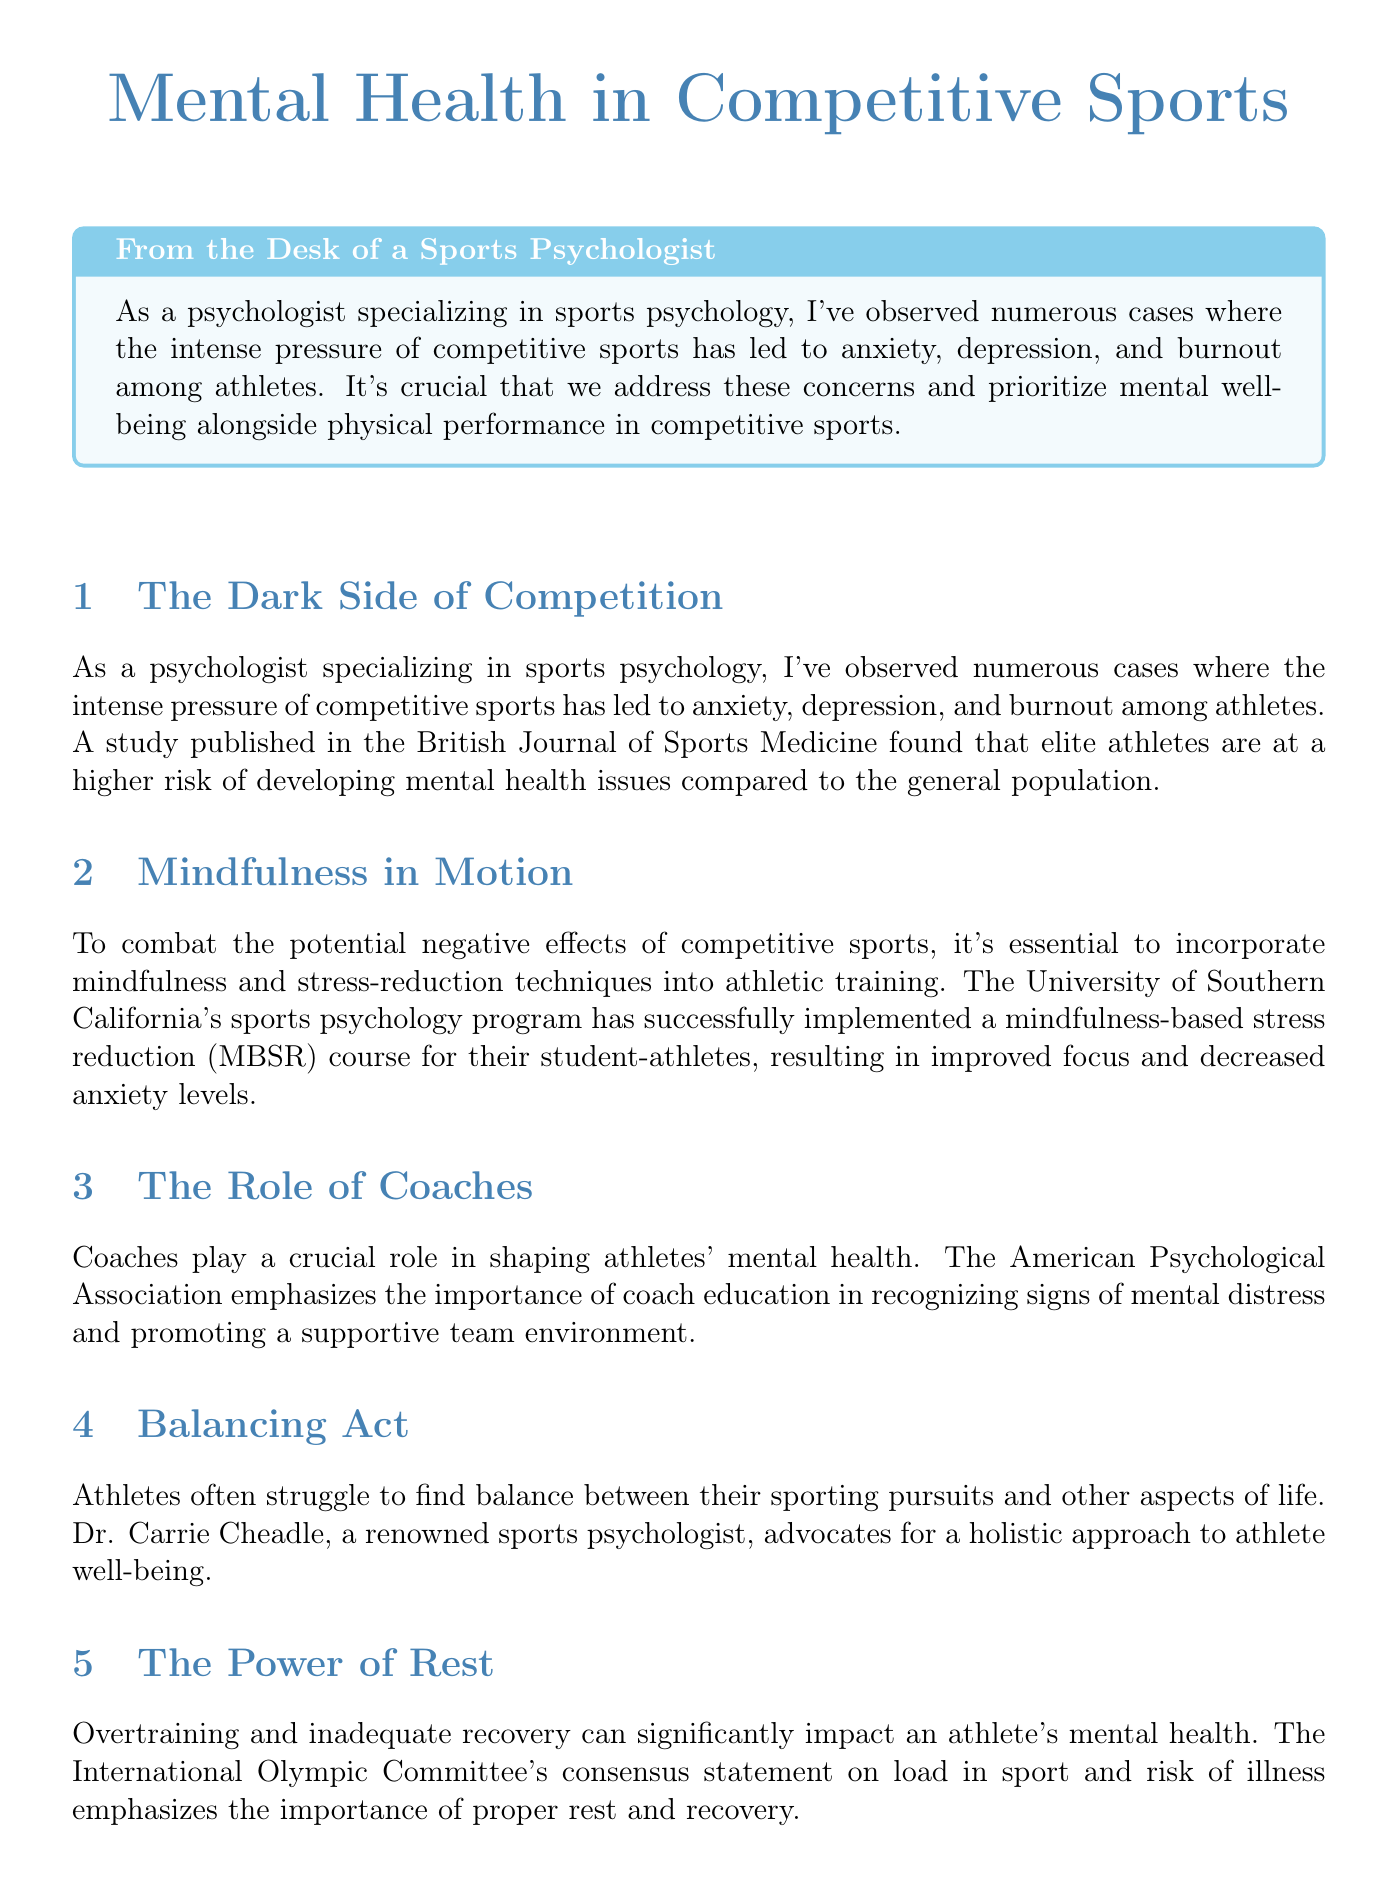What is the title of the newsletter? The title is prominently featured at the beginning of the document and reflects the main theme of the content.
Answer: Mental Health in Competitive Sports Who emphasizes the role of coaches in shaping athletes' mental health? This information is stated in the section discussing the role of coaches and their importance in mental health support.
Answer: American Psychological Association What type of techniques are discussed in the section "Mindfulness in Motion"? The content mentions these techniques as part of combatting negative effects in competitive sports.
Answer: Mindfulness and stress-reduction techniques What kind of mental health issues are elite athletes at higher risk for? The document specifies the types of mental health issues athletes may face in the competition context.
Answer: Anxiety, depression, and burnout Who is the case study focused on? This information is derived from the title of the case study included in the document.
Answer: Michael Phelps What is one resource mentioned for athletes seeking mental health support? Resources are listed in a dedicated section that provides support information for athletes.
Answer: Athletes for Hope What approach does Dr. Carrie Cheadle advocate for? This information is derived from the section titled "Balancing Act" discussing strategies for maintaining mental health.
Answer: Holistic approach What is the impact of overtraining on mental health according to the newsletter? The section discusses the implications of inadequate recovery related to mental health.
Answer: Significantly impacts mental health What does the expert quote from Dr. Claudia Reardon highlight? The quote addresses the balance between mental and physical performance in sports.
Answer: Prioritizing mental well-being 